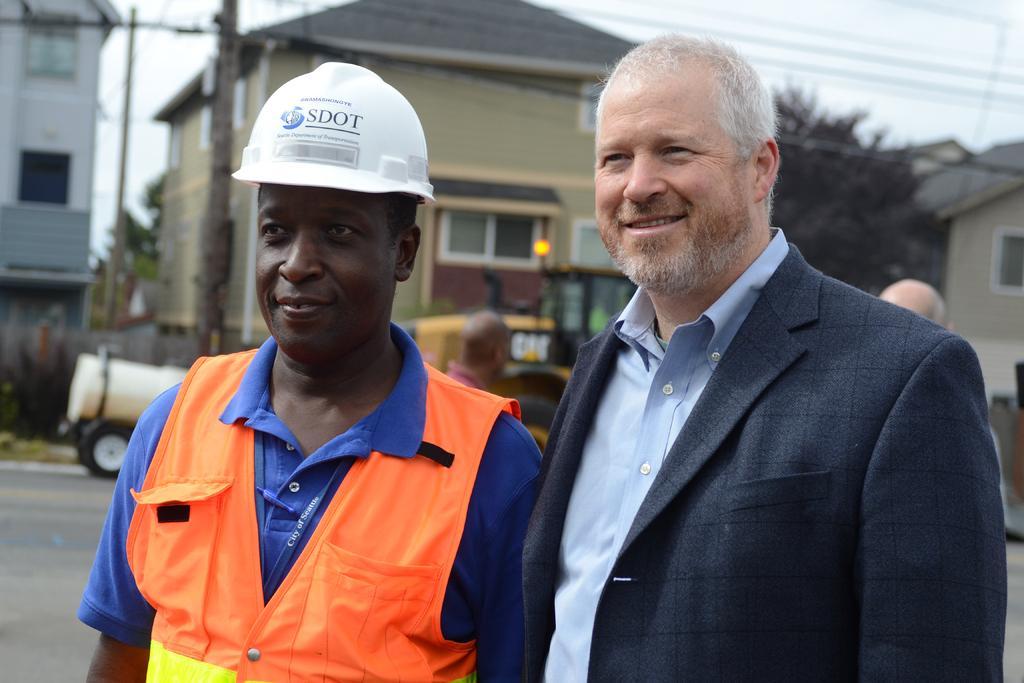Could you give a brief overview of what you see in this image? In the center of the image there are persons standing on the road. In the background we can see buildings, trees, poles, vehicles and sky. 